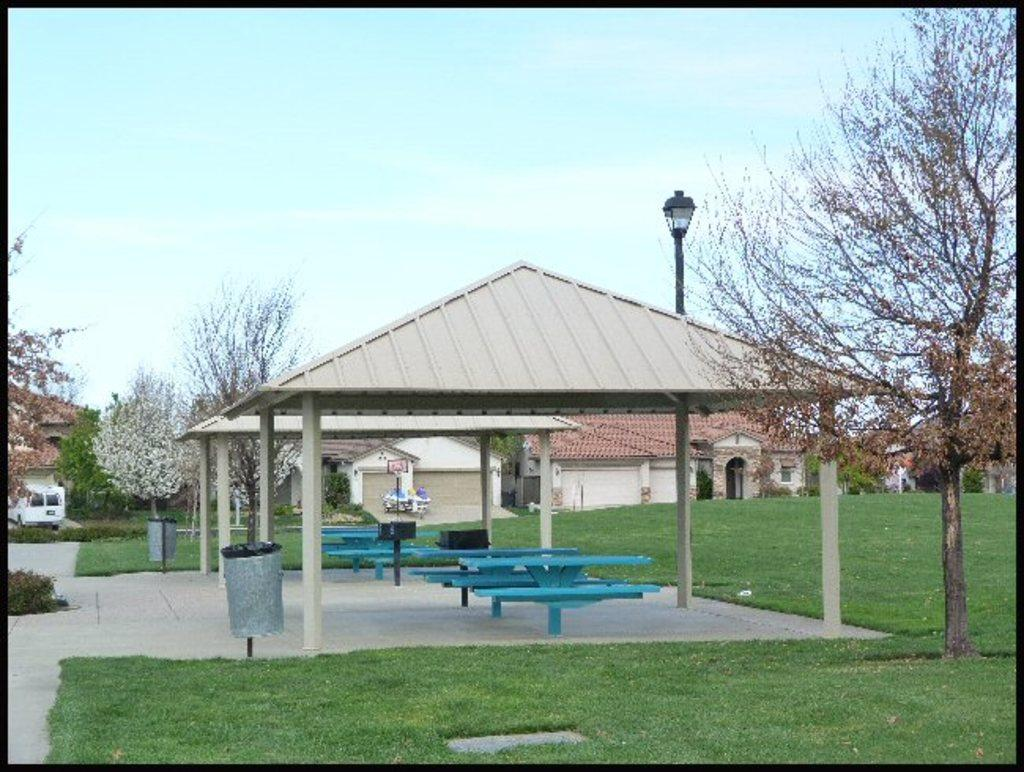What type of seating is visible in the image? There are blue benches in the image. What colors are the houses in the background? The houses in the background are in cream, white, and brown colors. What type of vegetation is present in the image? There are green trees in the image. What colors can be seen in the sky? The sky is blue and white in color. What advice is being given by the boot in the image? There is no boot present in the image, so no advice can be given. How many hoses are visible in the image? There are no hoses present in the image. 